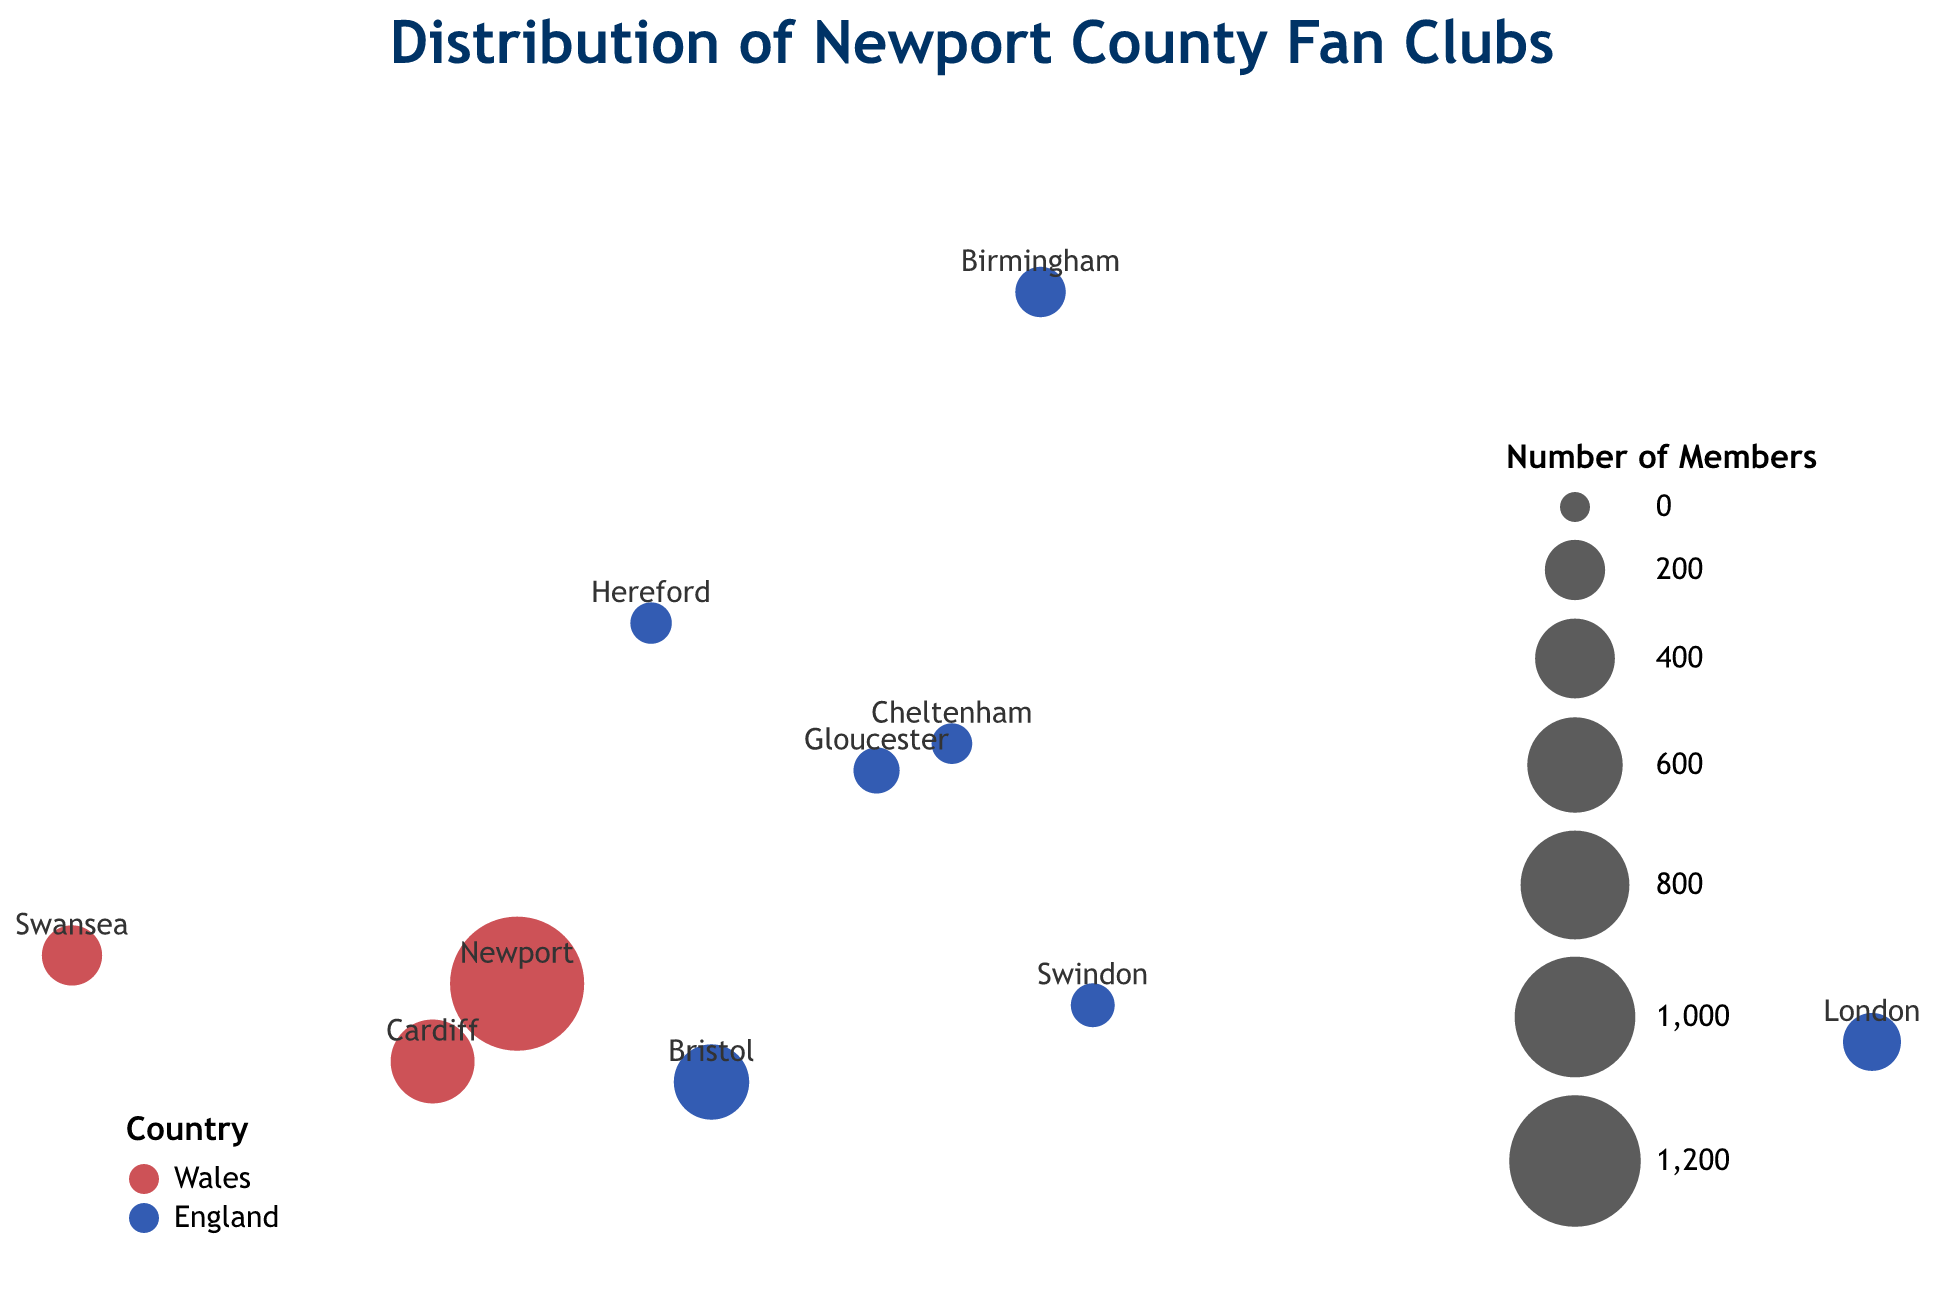What is the title of the plot? The title of the plot is the text displayed at the top of the figure. It gives a brief description of what the plot represents.
Answer: Distribution of Newport County Fan Clubs How many fan clubs are represented in the figure? Each circle in the figure represents a fan club, so we count the number of circles.
Answer: 10 Which city has the largest number of Newport County fan club members? The size of the circles represents the number of members. The largest circle indicates the city with the highest number of members.
Answer: Newport In which two countries are the Newport County fan clubs located? The legend in the plot uses colors to indicate the two countries. We can identify the country names from the legend.
Answer: Wales and England Which city in Wales has the smallest number of fans? By looking at the color-coded circles representing Wales (in red) and comparing their sizes, we find the smallest circle.
Answer: Swansea How many more members are there in Bristol compared to Hereford? Look at the circle sizes and their associated member counts for Bristol and Hereford. Subtract Hereford’s members from Bristol’s members. Bristol (350) - Hereford (60) = 290
Answer: 290 What is the average number of fan club members in England? Sum the number of members from all English cities and divide by the number of English cities. (350+180+120+90+75+60+55) / 7 = 930 / 7 ≈ 133
Answer: 133 Which city is closest to Newport based on geographic coordinates? By comparing the latitude and longitude values of the cities, the city with coordinates closest to Newport is identified.
Answer: Cardiff How many Welsh cities are represented in the plot? The cities in Wales are marked by a particular color (red) in the legend. Count the number of such circles.
Answer: 3 Which cities have fewer than 100 members in their Newport County fan clubs? Identify the cities with circles representing less than 100 members from their size and member count.
Answer: Gloucester, Swindon, Hereford, Cheltenham 